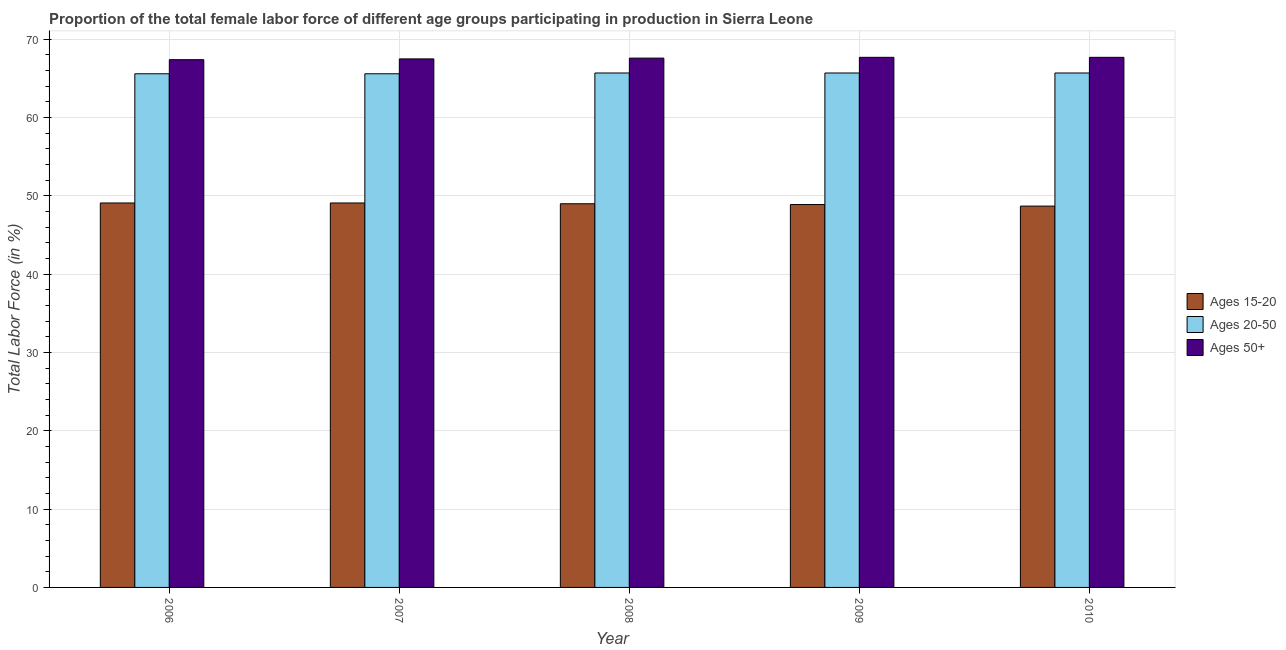How many different coloured bars are there?
Keep it short and to the point. 3. How many groups of bars are there?
Your answer should be compact. 5. Are the number of bars on each tick of the X-axis equal?
Your answer should be very brief. Yes. What is the percentage of female labor force within the age group 15-20 in 2007?
Provide a short and direct response. 49.1. Across all years, what is the maximum percentage of female labor force within the age group 20-50?
Provide a short and direct response. 65.7. Across all years, what is the minimum percentage of female labor force within the age group 15-20?
Make the answer very short. 48.7. What is the total percentage of female labor force within the age group 15-20 in the graph?
Your answer should be very brief. 244.8. What is the difference between the percentage of female labor force within the age group 20-50 in 2008 and that in 2010?
Make the answer very short. 0. What is the average percentage of female labor force above age 50 per year?
Offer a very short reply. 67.58. In the year 2009, what is the difference between the percentage of female labor force above age 50 and percentage of female labor force within the age group 20-50?
Make the answer very short. 0. In how many years, is the percentage of female labor force above age 50 greater than 62 %?
Your answer should be very brief. 5. What is the difference between the highest and the lowest percentage of female labor force within the age group 15-20?
Your answer should be compact. 0.4. Is the sum of the percentage of female labor force within the age group 15-20 in 2007 and 2010 greater than the maximum percentage of female labor force above age 50 across all years?
Your response must be concise. Yes. What does the 2nd bar from the left in 2009 represents?
Offer a very short reply. Ages 20-50. What does the 3rd bar from the right in 2008 represents?
Provide a succinct answer. Ages 15-20. How many bars are there?
Provide a short and direct response. 15. Are the values on the major ticks of Y-axis written in scientific E-notation?
Your answer should be very brief. No. Does the graph contain any zero values?
Ensure brevity in your answer.  No. What is the title of the graph?
Make the answer very short. Proportion of the total female labor force of different age groups participating in production in Sierra Leone. What is the label or title of the X-axis?
Your answer should be very brief. Year. What is the label or title of the Y-axis?
Your response must be concise. Total Labor Force (in %). What is the Total Labor Force (in %) in Ages 15-20 in 2006?
Your response must be concise. 49.1. What is the Total Labor Force (in %) of Ages 20-50 in 2006?
Offer a terse response. 65.6. What is the Total Labor Force (in %) of Ages 50+ in 2006?
Ensure brevity in your answer.  67.4. What is the Total Labor Force (in %) in Ages 15-20 in 2007?
Offer a terse response. 49.1. What is the Total Labor Force (in %) of Ages 20-50 in 2007?
Your response must be concise. 65.6. What is the Total Labor Force (in %) in Ages 50+ in 2007?
Provide a short and direct response. 67.5. What is the Total Labor Force (in %) of Ages 15-20 in 2008?
Your answer should be compact. 49. What is the Total Labor Force (in %) in Ages 20-50 in 2008?
Provide a short and direct response. 65.7. What is the Total Labor Force (in %) in Ages 50+ in 2008?
Your response must be concise. 67.6. What is the Total Labor Force (in %) in Ages 15-20 in 2009?
Give a very brief answer. 48.9. What is the Total Labor Force (in %) of Ages 20-50 in 2009?
Ensure brevity in your answer.  65.7. What is the Total Labor Force (in %) in Ages 50+ in 2009?
Ensure brevity in your answer.  67.7. What is the Total Labor Force (in %) in Ages 15-20 in 2010?
Make the answer very short. 48.7. What is the Total Labor Force (in %) of Ages 20-50 in 2010?
Your response must be concise. 65.7. What is the Total Labor Force (in %) in Ages 50+ in 2010?
Make the answer very short. 67.7. Across all years, what is the maximum Total Labor Force (in %) in Ages 15-20?
Your answer should be compact. 49.1. Across all years, what is the maximum Total Labor Force (in %) in Ages 20-50?
Give a very brief answer. 65.7. Across all years, what is the maximum Total Labor Force (in %) of Ages 50+?
Give a very brief answer. 67.7. Across all years, what is the minimum Total Labor Force (in %) in Ages 15-20?
Ensure brevity in your answer.  48.7. Across all years, what is the minimum Total Labor Force (in %) of Ages 20-50?
Provide a succinct answer. 65.6. Across all years, what is the minimum Total Labor Force (in %) of Ages 50+?
Make the answer very short. 67.4. What is the total Total Labor Force (in %) of Ages 15-20 in the graph?
Give a very brief answer. 244.8. What is the total Total Labor Force (in %) of Ages 20-50 in the graph?
Your answer should be compact. 328.3. What is the total Total Labor Force (in %) of Ages 50+ in the graph?
Offer a very short reply. 337.9. What is the difference between the Total Labor Force (in %) in Ages 15-20 in 2006 and that in 2007?
Offer a very short reply. 0. What is the difference between the Total Labor Force (in %) in Ages 20-50 in 2006 and that in 2007?
Make the answer very short. 0. What is the difference between the Total Labor Force (in %) in Ages 15-20 in 2006 and that in 2008?
Offer a very short reply. 0.1. What is the difference between the Total Labor Force (in %) of Ages 20-50 in 2006 and that in 2008?
Provide a short and direct response. -0.1. What is the difference between the Total Labor Force (in %) in Ages 15-20 in 2006 and that in 2009?
Provide a succinct answer. 0.2. What is the difference between the Total Labor Force (in %) of Ages 20-50 in 2006 and that in 2009?
Your response must be concise. -0.1. What is the difference between the Total Labor Force (in %) of Ages 15-20 in 2006 and that in 2010?
Your answer should be very brief. 0.4. What is the difference between the Total Labor Force (in %) in Ages 20-50 in 2006 and that in 2010?
Offer a very short reply. -0.1. What is the difference between the Total Labor Force (in %) in Ages 20-50 in 2007 and that in 2008?
Provide a short and direct response. -0.1. What is the difference between the Total Labor Force (in %) of Ages 15-20 in 2007 and that in 2009?
Your answer should be very brief. 0.2. What is the difference between the Total Labor Force (in %) of Ages 15-20 in 2007 and that in 2010?
Make the answer very short. 0.4. What is the difference between the Total Labor Force (in %) of Ages 20-50 in 2007 and that in 2010?
Make the answer very short. -0.1. What is the difference between the Total Labor Force (in %) of Ages 50+ in 2007 and that in 2010?
Your answer should be compact. -0.2. What is the difference between the Total Labor Force (in %) of Ages 15-20 in 2008 and that in 2009?
Make the answer very short. 0.1. What is the difference between the Total Labor Force (in %) in Ages 15-20 in 2008 and that in 2010?
Keep it short and to the point. 0.3. What is the difference between the Total Labor Force (in %) of Ages 20-50 in 2008 and that in 2010?
Offer a very short reply. 0. What is the difference between the Total Labor Force (in %) of Ages 50+ in 2008 and that in 2010?
Give a very brief answer. -0.1. What is the difference between the Total Labor Force (in %) of Ages 15-20 in 2009 and that in 2010?
Give a very brief answer. 0.2. What is the difference between the Total Labor Force (in %) of Ages 20-50 in 2009 and that in 2010?
Give a very brief answer. 0. What is the difference between the Total Labor Force (in %) in Ages 15-20 in 2006 and the Total Labor Force (in %) in Ages 20-50 in 2007?
Your answer should be very brief. -16.5. What is the difference between the Total Labor Force (in %) of Ages 15-20 in 2006 and the Total Labor Force (in %) of Ages 50+ in 2007?
Make the answer very short. -18.4. What is the difference between the Total Labor Force (in %) in Ages 20-50 in 2006 and the Total Labor Force (in %) in Ages 50+ in 2007?
Your answer should be compact. -1.9. What is the difference between the Total Labor Force (in %) in Ages 15-20 in 2006 and the Total Labor Force (in %) in Ages 20-50 in 2008?
Make the answer very short. -16.6. What is the difference between the Total Labor Force (in %) of Ages 15-20 in 2006 and the Total Labor Force (in %) of Ages 50+ in 2008?
Your answer should be compact. -18.5. What is the difference between the Total Labor Force (in %) of Ages 15-20 in 2006 and the Total Labor Force (in %) of Ages 20-50 in 2009?
Give a very brief answer. -16.6. What is the difference between the Total Labor Force (in %) of Ages 15-20 in 2006 and the Total Labor Force (in %) of Ages 50+ in 2009?
Ensure brevity in your answer.  -18.6. What is the difference between the Total Labor Force (in %) of Ages 20-50 in 2006 and the Total Labor Force (in %) of Ages 50+ in 2009?
Offer a terse response. -2.1. What is the difference between the Total Labor Force (in %) in Ages 15-20 in 2006 and the Total Labor Force (in %) in Ages 20-50 in 2010?
Ensure brevity in your answer.  -16.6. What is the difference between the Total Labor Force (in %) in Ages 15-20 in 2006 and the Total Labor Force (in %) in Ages 50+ in 2010?
Make the answer very short. -18.6. What is the difference between the Total Labor Force (in %) in Ages 15-20 in 2007 and the Total Labor Force (in %) in Ages 20-50 in 2008?
Provide a short and direct response. -16.6. What is the difference between the Total Labor Force (in %) in Ages 15-20 in 2007 and the Total Labor Force (in %) in Ages 50+ in 2008?
Your answer should be compact. -18.5. What is the difference between the Total Labor Force (in %) in Ages 20-50 in 2007 and the Total Labor Force (in %) in Ages 50+ in 2008?
Offer a very short reply. -2. What is the difference between the Total Labor Force (in %) in Ages 15-20 in 2007 and the Total Labor Force (in %) in Ages 20-50 in 2009?
Ensure brevity in your answer.  -16.6. What is the difference between the Total Labor Force (in %) in Ages 15-20 in 2007 and the Total Labor Force (in %) in Ages 50+ in 2009?
Offer a very short reply. -18.6. What is the difference between the Total Labor Force (in %) of Ages 20-50 in 2007 and the Total Labor Force (in %) of Ages 50+ in 2009?
Your answer should be very brief. -2.1. What is the difference between the Total Labor Force (in %) of Ages 15-20 in 2007 and the Total Labor Force (in %) of Ages 20-50 in 2010?
Offer a terse response. -16.6. What is the difference between the Total Labor Force (in %) in Ages 15-20 in 2007 and the Total Labor Force (in %) in Ages 50+ in 2010?
Ensure brevity in your answer.  -18.6. What is the difference between the Total Labor Force (in %) of Ages 20-50 in 2007 and the Total Labor Force (in %) of Ages 50+ in 2010?
Your response must be concise. -2.1. What is the difference between the Total Labor Force (in %) of Ages 15-20 in 2008 and the Total Labor Force (in %) of Ages 20-50 in 2009?
Your answer should be very brief. -16.7. What is the difference between the Total Labor Force (in %) of Ages 15-20 in 2008 and the Total Labor Force (in %) of Ages 50+ in 2009?
Your answer should be very brief. -18.7. What is the difference between the Total Labor Force (in %) in Ages 20-50 in 2008 and the Total Labor Force (in %) in Ages 50+ in 2009?
Provide a short and direct response. -2. What is the difference between the Total Labor Force (in %) of Ages 15-20 in 2008 and the Total Labor Force (in %) of Ages 20-50 in 2010?
Your response must be concise. -16.7. What is the difference between the Total Labor Force (in %) in Ages 15-20 in 2008 and the Total Labor Force (in %) in Ages 50+ in 2010?
Your answer should be very brief. -18.7. What is the difference between the Total Labor Force (in %) of Ages 20-50 in 2008 and the Total Labor Force (in %) of Ages 50+ in 2010?
Ensure brevity in your answer.  -2. What is the difference between the Total Labor Force (in %) of Ages 15-20 in 2009 and the Total Labor Force (in %) of Ages 20-50 in 2010?
Offer a very short reply. -16.8. What is the difference between the Total Labor Force (in %) of Ages 15-20 in 2009 and the Total Labor Force (in %) of Ages 50+ in 2010?
Your response must be concise. -18.8. What is the difference between the Total Labor Force (in %) in Ages 20-50 in 2009 and the Total Labor Force (in %) in Ages 50+ in 2010?
Offer a very short reply. -2. What is the average Total Labor Force (in %) in Ages 15-20 per year?
Make the answer very short. 48.96. What is the average Total Labor Force (in %) in Ages 20-50 per year?
Your answer should be very brief. 65.66. What is the average Total Labor Force (in %) of Ages 50+ per year?
Ensure brevity in your answer.  67.58. In the year 2006, what is the difference between the Total Labor Force (in %) in Ages 15-20 and Total Labor Force (in %) in Ages 20-50?
Your answer should be very brief. -16.5. In the year 2006, what is the difference between the Total Labor Force (in %) in Ages 15-20 and Total Labor Force (in %) in Ages 50+?
Offer a terse response. -18.3. In the year 2007, what is the difference between the Total Labor Force (in %) of Ages 15-20 and Total Labor Force (in %) of Ages 20-50?
Provide a succinct answer. -16.5. In the year 2007, what is the difference between the Total Labor Force (in %) in Ages 15-20 and Total Labor Force (in %) in Ages 50+?
Make the answer very short. -18.4. In the year 2008, what is the difference between the Total Labor Force (in %) in Ages 15-20 and Total Labor Force (in %) in Ages 20-50?
Provide a succinct answer. -16.7. In the year 2008, what is the difference between the Total Labor Force (in %) of Ages 15-20 and Total Labor Force (in %) of Ages 50+?
Offer a terse response. -18.6. In the year 2009, what is the difference between the Total Labor Force (in %) in Ages 15-20 and Total Labor Force (in %) in Ages 20-50?
Your answer should be very brief. -16.8. In the year 2009, what is the difference between the Total Labor Force (in %) of Ages 15-20 and Total Labor Force (in %) of Ages 50+?
Your answer should be compact. -18.8. In the year 2010, what is the difference between the Total Labor Force (in %) in Ages 15-20 and Total Labor Force (in %) in Ages 50+?
Your answer should be compact. -19. What is the ratio of the Total Labor Force (in %) in Ages 20-50 in 2006 to that in 2007?
Give a very brief answer. 1. What is the ratio of the Total Labor Force (in %) of Ages 50+ in 2006 to that in 2007?
Ensure brevity in your answer.  1. What is the ratio of the Total Labor Force (in %) of Ages 50+ in 2006 to that in 2008?
Your answer should be very brief. 1. What is the ratio of the Total Labor Force (in %) of Ages 15-20 in 2006 to that in 2009?
Your answer should be compact. 1. What is the ratio of the Total Labor Force (in %) in Ages 20-50 in 2006 to that in 2009?
Provide a succinct answer. 1. What is the ratio of the Total Labor Force (in %) in Ages 15-20 in 2006 to that in 2010?
Ensure brevity in your answer.  1.01. What is the ratio of the Total Labor Force (in %) in Ages 20-50 in 2006 to that in 2010?
Your answer should be very brief. 1. What is the ratio of the Total Labor Force (in %) of Ages 20-50 in 2007 to that in 2008?
Ensure brevity in your answer.  1. What is the ratio of the Total Labor Force (in %) in Ages 15-20 in 2007 to that in 2009?
Offer a very short reply. 1. What is the ratio of the Total Labor Force (in %) of Ages 50+ in 2007 to that in 2009?
Provide a short and direct response. 1. What is the ratio of the Total Labor Force (in %) of Ages 15-20 in 2007 to that in 2010?
Offer a terse response. 1.01. What is the ratio of the Total Labor Force (in %) in Ages 50+ in 2007 to that in 2010?
Offer a terse response. 1. What is the ratio of the Total Labor Force (in %) of Ages 15-20 in 2008 to that in 2009?
Give a very brief answer. 1. What is the ratio of the Total Labor Force (in %) in Ages 20-50 in 2008 to that in 2009?
Offer a terse response. 1. What is the ratio of the Total Labor Force (in %) in Ages 50+ in 2008 to that in 2009?
Make the answer very short. 1. What is the ratio of the Total Labor Force (in %) in Ages 50+ in 2008 to that in 2010?
Your answer should be compact. 1. What is the ratio of the Total Labor Force (in %) of Ages 15-20 in 2009 to that in 2010?
Your answer should be compact. 1. What is the ratio of the Total Labor Force (in %) of Ages 20-50 in 2009 to that in 2010?
Give a very brief answer. 1. What is the ratio of the Total Labor Force (in %) in Ages 50+ in 2009 to that in 2010?
Ensure brevity in your answer.  1. What is the difference between the highest and the second highest Total Labor Force (in %) of Ages 15-20?
Offer a very short reply. 0. What is the difference between the highest and the second highest Total Labor Force (in %) in Ages 50+?
Your answer should be very brief. 0. What is the difference between the highest and the lowest Total Labor Force (in %) of Ages 15-20?
Keep it short and to the point. 0.4. 